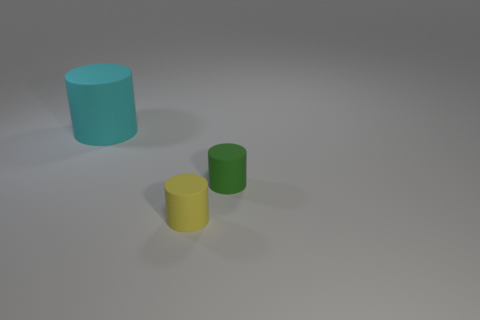There is another small object that is the same material as the tiny green thing; what is its color? The small object that shares the same material as the tiny green cylinder is yellow in color. This reflects that despite the difference in their hues, the physical properties such as texture and material finish are consistent between the two. 